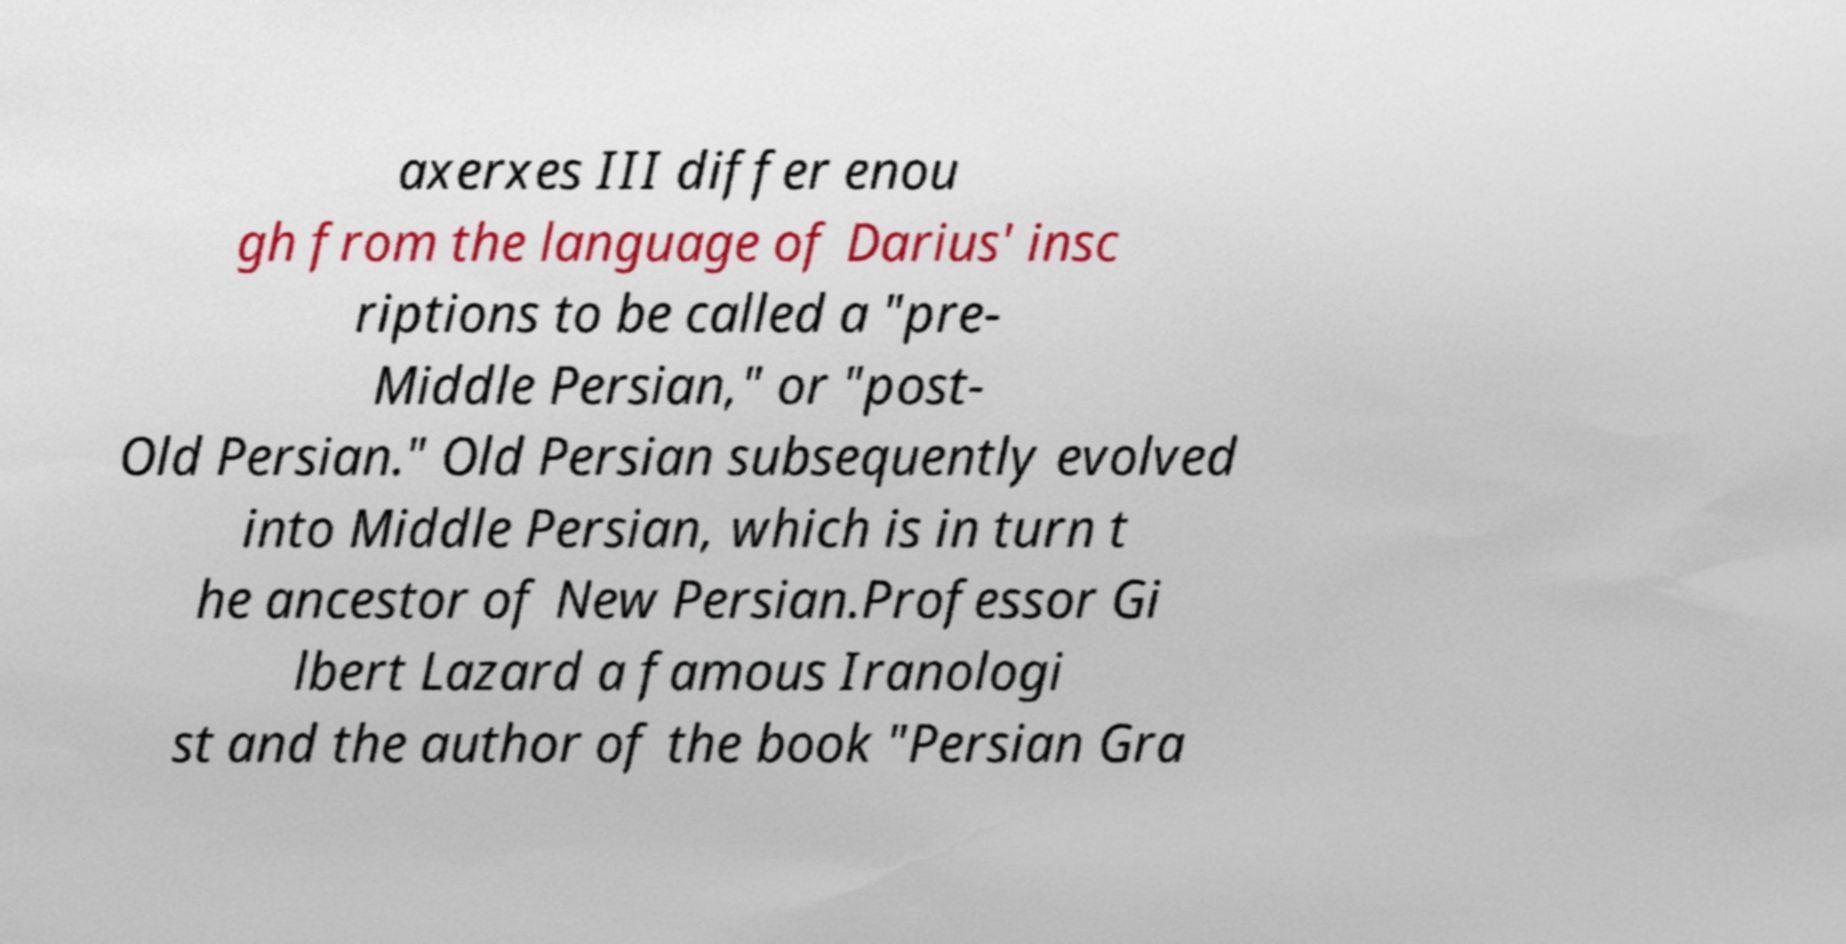Please read and relay the text visible in this image. What does it say? axerxes III differ enou gh from the language of Darius' insc riptions to be called a "pre- Middle Persian," or "post- Old Persian." Old Persian subsequently evolved into Middle Persian, which is in turn t he ancestor of New Persian.Professor Gi lbert Lazard a famous Iranologi st and the author of the book "Persian Gra 